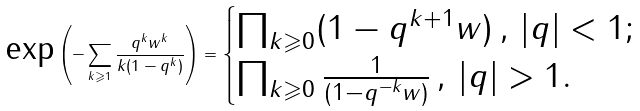Convert formula to latex. <formula><loc_0><loc_0><loc_500><loc_500>\text {exp} \left ( - \sum _ { k \geqslant 1 } \frac { q ^ { k } w ^ { k } } { k ( 1 - q ^ { k } ) } \right ) = \begin{cases} \prod _ { k \geqslant 0 } ( 1 - q ^ { k + 1 } w ) \, , \, | q | < 1 ; \\ \prod _ { k \geqslant 0 } \frac { 1 } { ( 1 - q ^ { - k } w ) } \, , \, | q | > 1 . \end{cases}</formula> 